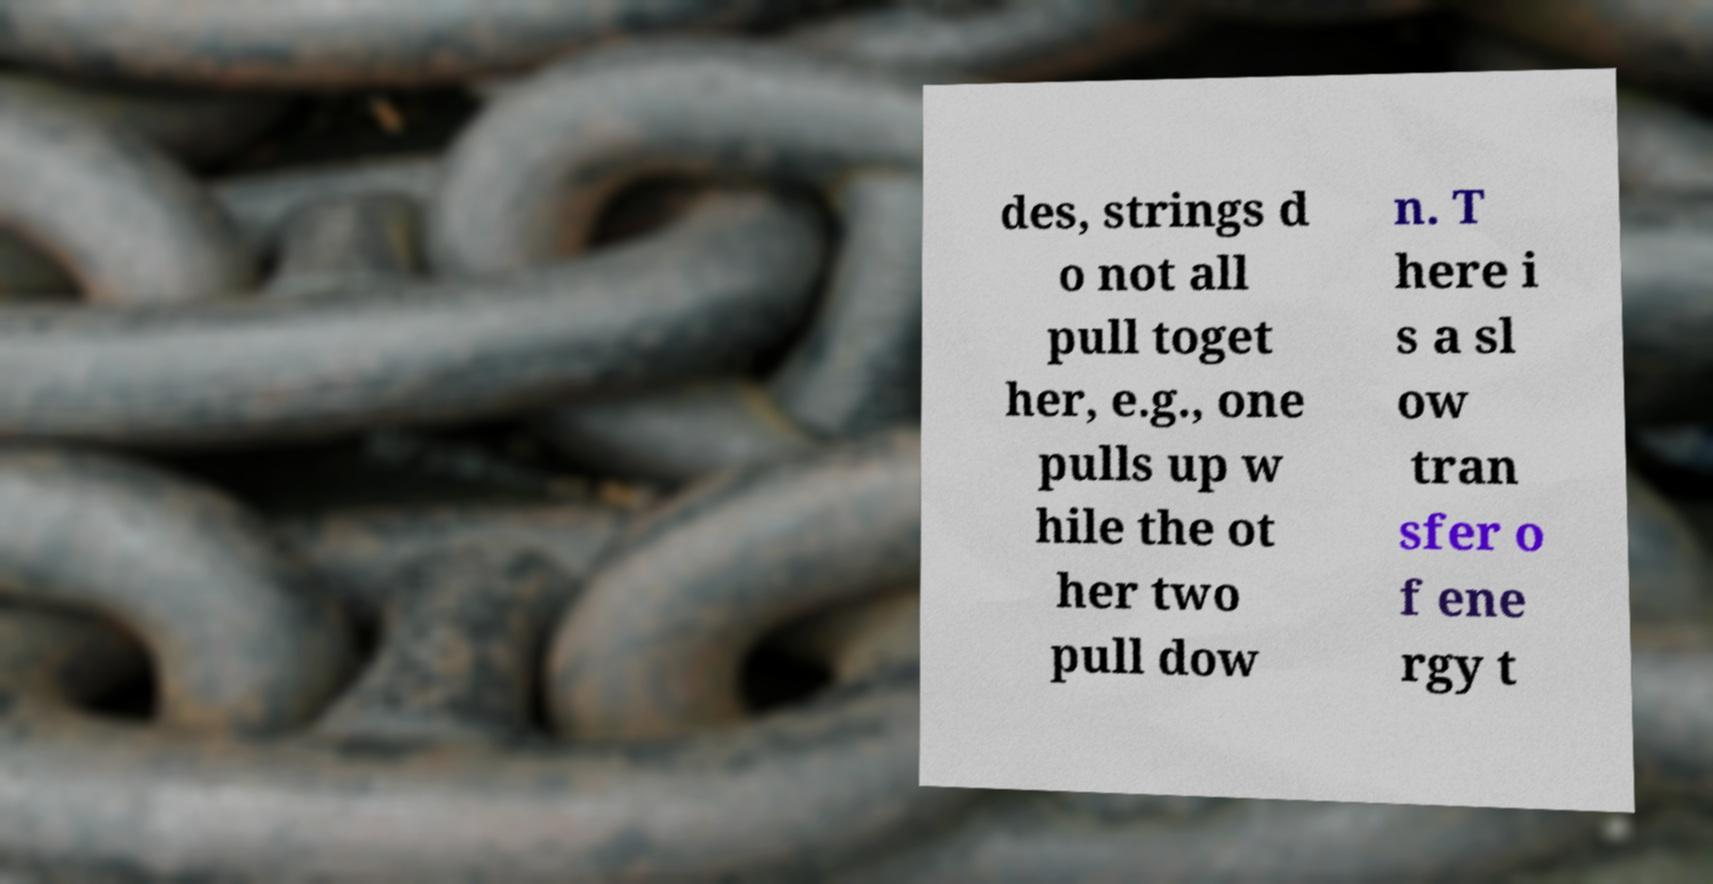Can you accurately transcribe the text from the provided image for me? des, strings d o not all pull toget her, e.g., one pulls up w hile the ot her two pull dow n. T here i s a sl ow tran sfer o f ene rgy t 